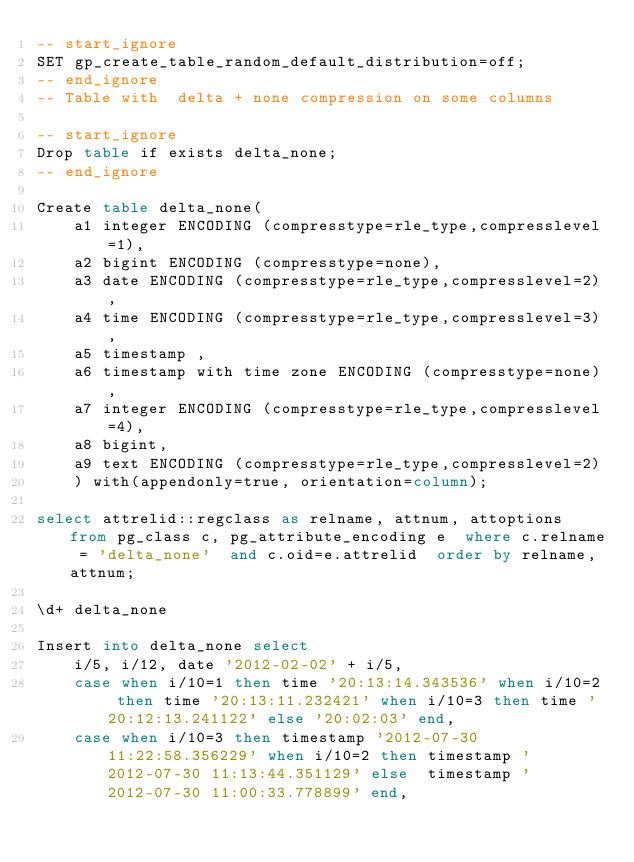Convert code to text. <code><loc_0><loc_0><loc_500><loc_500><_SQL_>-- start_ignore
SET gp_create_table_random_default_distribution=off;
-- end_ignore
-- Table with  delta + none compression on some columns

-- start_ignore
Drop table if exists delta_none;
-- end_ignore

Create table delta_none(
    a1 integer ENCODING (compresstype=rle_type,compresslevel=1),
    a2 bigint ENCODING (compresstype=none),
    a3 date ENCODING (compresstype=rle_type,compresslevel=2),
    a4 time ENCODING (compresstype=rle_type,compresslevel=3),
    a5 timestamp ,
    a6 timestamp with time zone ENCODING (compresstype=none),
    a7 integer ENCODING (compresstype=rle_type,compresslevel=4),
    a8 bigint,
    a9 text ENCODING (compresstype=rle_type,compresslevel=2)
    ) with(appendonly=true, orientation=column);

select attrelid::regclass as relname, attnum, attoptions from pg_class c, pg_attribute_encoding e  where c.relname = 'delta_none'  and c.oid=e.attrelid  order by relname, attnum;

\d+ delta_none

Insert into delta_none select
    i/5, i/12, date '2012-02-02' + i/5,
    case when i/10=1 then time '20:13:14.343536' when i/10=2 then time '20:13:11.232421' when i/10=3 then time '20:12:13.241122' else '20:02:03' end,
    case when i/10=3 then timestamp '2012-07-30 11:22:58.356229' when i/10=2 then timestamp '2012-07-30 11:13:44.351129' else  timestamp '2012-07-30 11:00:33.778899' end,</code> 